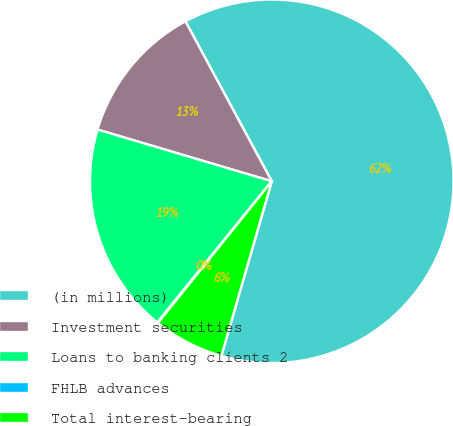<chart> <loc_0><loc_0><loc_500><loc_500><pie_chart><fcel>(in millions)<fcel>Investment securities<fcel>Loans to banking clients 2<fcel>FHLB advances<fcel>Total interest-bearing<nl><fcel>62.35%<fcel>12.53%<fcel>18.75%<fcel>0.07%<fcel>6.3%<nl></chart> 